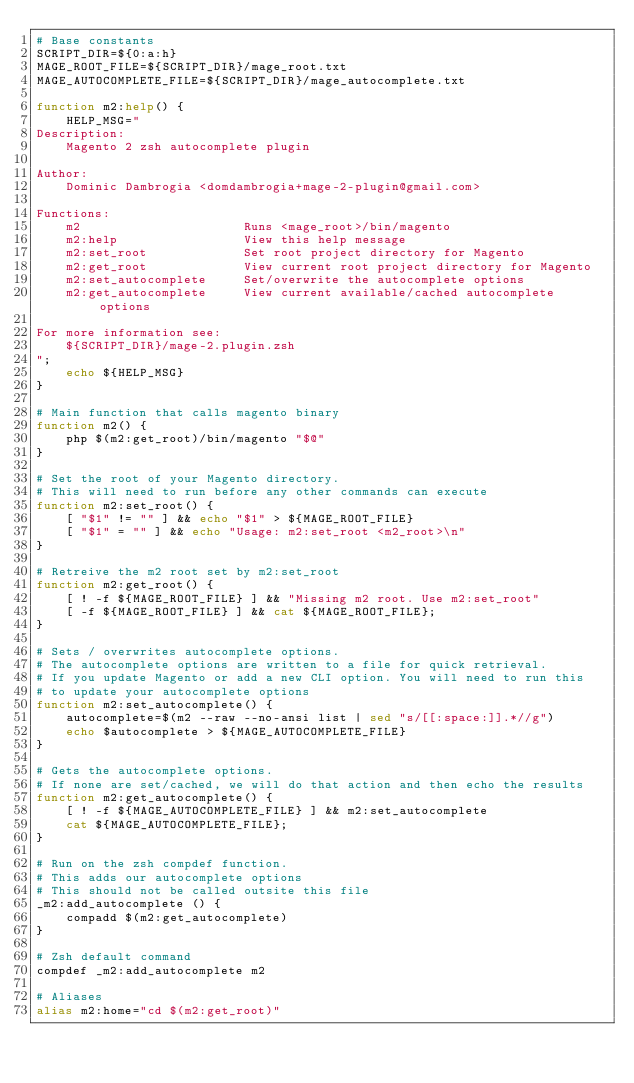<code> <loc_0><loc_0><loc_500><loc_500><_Bash_># Base constants
SCRIPT_DIR=${0:a:h}
MAGE_ROOT_FILE=${SCRIPT_DIR}/mage_root.txt
MAGE_AUTOCOMPLETE_FILE=${SCRIPT_DIR}/mage_autocomplete.txt

function m2:help() {
    HELP_MSG="
Description:
    Magento 2 zsh autocomplete plugin

Author:
    Dominic Dambrogia <domdambrogia+mage-2-plugin@gmail.com>

Functions:
    m2                      Runs <mage_root>/bin/magento
    m2:help                 View this help message
    m2:set_root             Set root project directory for Magento
    m2:get_root             View current root project directory for Magento
    m2:set_autocomplete     Set/overwrite the autocomplete options
    m2:get_autocomplete     View current available/cached autocomplete options

For more information see:
    ${SCRIPT_DIR}/mage-2.plugin.zsh
";
    echo ${HELP_MSG}
}

# Main function that calls magento binary
function m2() {
	php $(m2:get_root)/bin/magento "$@"
}

# Set the root of your Magento directory.
# This will need to run before any other commands can execute
function m2:set_root() {
    [ "$1" != "" ] && echo "$1" > ${MAGE_ROOT_FILE}
    [ "$1" = "" ] && echo "Usage: m2:set_root <m2_root>\n"
}

# Retreive the m2 root set by m2:set_root
function m2:get_root() {
	[ ! -f ${MAGE_ROOT_FILE} ] && "Missing m2 root. Use m2:set_root"
	[ -f ${MAGE_ROOT_FILE} ] && cat ${MAGE_ROOT_FILE};
}

# Sets / overwrites autocomplete options.
# The autocomplete options are written to a file for quick retrieval.
# If you update Magento or add a new CLI option. You will need to run this
# to update your autocomplete options
function m2:set_autocomplete() {
    autocomplete=$(m2 --raw --no-ansi list | sed "s/[[:space:]].*//g")
    echo $autocomplete > ${MAGE_AUTOCOMPLETE_FILE}
}

# Gets the autocomplete options.
# If none are set/cached, we will do that action and then echo the results
function m2:get_autocomplete() {
	[ ! -f ${MAGE_AUTOCOMPLETE_FILE} ] && m2:set_autocomplete
    cat ${MAGE_AUTOCOMPLETE_FILE};
}

# Run on the zsh compdef function.
# This adds our autocomplete options
# This should not be called outsite this file
_m2:add_autocomplete () {
	compadd $(m2:get_autocomplete)
}

# Zsh default command
compdef _m2:add_autocomplete m2

# Aliases
alias m2:home="cd $(m2:get_root)"

</code> 